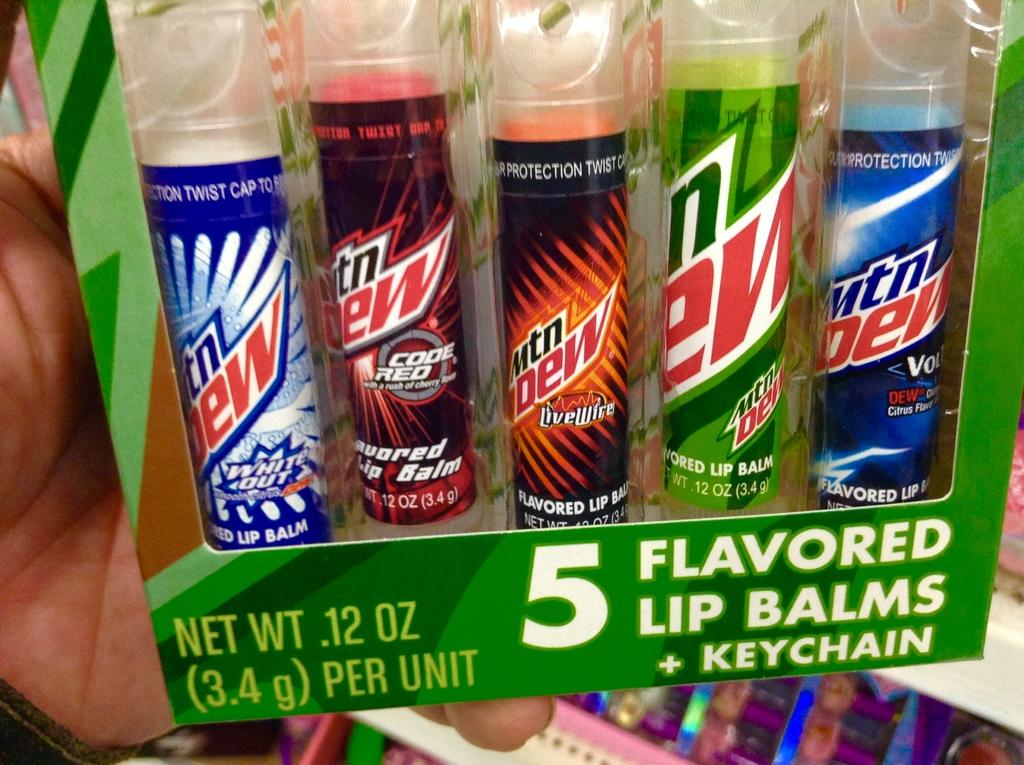<image>
Render a clear and concise summary of the photo. 5 flavored lip balms sitting with each other 